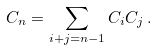<formula> <loc_0><loc_0><loc_500><loc_500>C _ { n } = \sum _ { i + j = n - 1 } C _ { i } C _ { j } \, .</formula> 